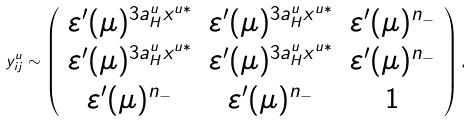<formula> <loc_0><loc_0><loc_500><loc_500>y ^ { u } _ { i j } \sim \left ( \begin{array} { c c c } \varepsilon ^ { \prime } ( \mu ) ^ { 3 a ^ { u } _ { H } x ^ { u * } } & \varepsilon ^ { \prime } ( \mu ) ^ { 3 a ^ { u } _ { H } x ^ { u * } } & \varepsilon ^ { \prime } ( \mu ) ^ { n _ { - } } \\ \varepsilon ^ { \prime } ( \mu ) ^ { 3 a ^ { u } _ { H } x ^ { u * } } & \varepsilon ^ { \prime } ( \mu ) ^ { 3 a ^ { u } _ { H } x ^ { u * } } & \varepsilon ^ { \prime } ( \mu ) ^ { n _ { - } } \\ \varepsilon ^ { \prime } ( \mu ) ^ { n _ { - } } & \varepsilon ^ { \prime } ( \mu ) ^ { n _ { - } } & 1 \end{array} \right ) ,</formula> 